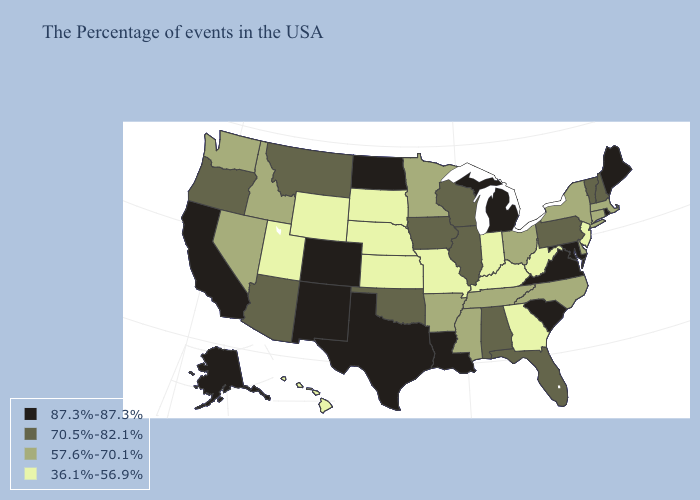What is the lowest value in states that border Alabama?
Concise answer only. 36.1%-56.9%. Name the states that have a value in the range 70.5%-82.1%?
Give a very brief answer. New Hampshire, Vermont, Pennsylvania, Florida, Alabama, Wisconsin, Illinois, Iowa, Oklahoma, Montana, Arizona, Oregon. Does Minnesota have a lower value than Nevada?
Concise answer only. No. Is the legend a continuous bar?
Answer briefly. No. Among the states that border New York , does New Jersey have the lowest value?
Write a very short answer. Yes. Among the states that border Kansas , does Oklahoma have the highest value?
Write a very short answer. No. Name the states that have a value in the range 36.1%-56.9%?
Write a very short answer. New Jersey, West Virginia, Georgia, Kentucky, Indiana, Missouri, Kansas, Nebraska, South Dakota, Wyoming, Utah, Hawaii. Among the states that border Minnesota , which have the highest value?
Write a very short answer. North Dakota. Among the states that border Oklahoma , which have the highest value?
Short answer required. Texas, Colorado, New Mexico. Does Ohio have the lowest value in the MidWest?
Concise answer only. No. Does Wisconsin have the lowest value in the MidWest?
Short answer required. No. Does the first symbol in the legend represent the smallest category?
Write a very short answer. No. Which states hav the highest value in the South?
Write a very short answer. Maryland, Virginia, South Carolina, Louisiana, Texas. Name the states that have a value in the range 70.5%-82.1%?
Give a very brief answer. New Hampshire, Vermont, Pennsylvania, Florida, Alabama, Wisconsin, Illinois, Iowa, Oklahoma, Montana, Arizona, Oregon. Name the states that have a value in the range 57.6%-70.1%?
Answer briefly. Massachusetts, Connecticut, New York, Delaware, North Carolina, Ohio, Tennessee, Mississippi, Arkansas, Minnesota, Idaho, Nevada, Washington. 